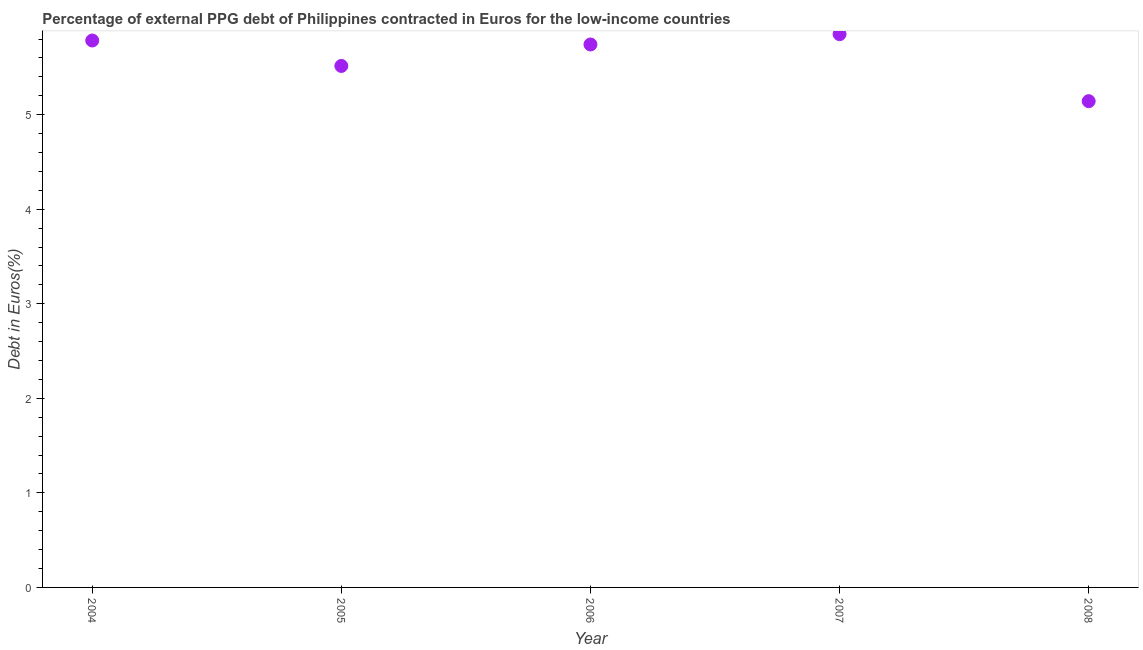What is the currency composition of ppg debt in 2004?
Your response must be concise. 5.79. Across all years, what is the maximum currency composition of ppg debt?
Offer a terse response. 5.85. Across all years, what is the minimum currency composition of ppg debt?
Ensure brevity in your answer.  5.14. In which year was the currency composition of ppg debt maximum?
Offer a terse response. 2007. In which year was the currency composition of ppg debt minimum?
Provide a short and direct response. 2008. What is the sum of the currency composition of ppg debt?
Make the answer very short. 28.04. What is the difference between the currency composition of ppg debt in 2005 and 2007?
Provide a short and direct response. -0.34. What is the average currency composition of ppg debt per year?
Your response must be concise. 5.61. What is the median currency composition of ppg debt?
Your answer should be compact. 5.74. In how many years, is the currency composition of ppg debt greater than 4.2 %?
Your response must be concise. 5. Do a majority of the years between 2006 and 2008 (inclusive) have currency composition of ppg debt greater than 0.2 %?
Your answer should be very brief. Yes. What is the ratio of the currency composition of ppg debt in 2004 to that in 2006?
Provide a succinct answer. 1.01. Is the difference between the currency composition of ppg debt in 2006 and 2007 greater than the difference between any two years?
Offer a terse response. No. What is the difference between the highest and the second highest currency composition of ppg debt?
Your answer should be compact. 0.07. What is the difference between the highest and the lowest currency composition of ppg debt?
Your answer should be compact. 0.71. Does the currency composition of ppg debt monotonically increase over the years?
Ensure brevity in your answer.  No. How many dotlines are there?
Offer a terse response. 1. Does the graph contain any zero values?
Your response must be concise. No. Does the graph contain grids?
Your answer should be very brief. No. What is the title of the graph?
Provide a short and direct response. Percentage of external PPG debt of Philippines contracted in Euros for the low-income countries. What is the label or title of the Y-axis?
Your response must be concise. Debt in Euros(%). What is the Debt in Euros(%) in 2004?
Your response must be concise. 5.79. What is the Debt in Euros(%) in 2005?
Give a very brief answer. 5.52. What is the Debt in Euros(%) in 2006?
Your response must be concise. 5.74. What is the Debt in Euros(%) in 2007?
Keep it short and to the point. 5.85. What is the Debt in Euros(%) in 2008?
Your answer should be compact. 5.14. What is the difference between the Debt in Euros(%) in 2004 and 2005?
Ensure brevity in your answer.  0.27. What is the difference between the Debt in Euros(%) in 2004 and 2006?
Your answer should be compact. 0.04. What is the difference between the Debt in Euros(%) in 2004 and 2007?
Your response must be concise. -0.07. What is the difference between the Debt in Euros(%) in 2004 and 2008?
Keep it short and to the point. 0.64. What is the difference between the Debt in Euros(%) in 2005 and 2006?
Your answer should be very brief. -0.23. What is the difference between the Debt in Euros(%) in 2005 and 2007?
Keep it short and to the point. -0.34. What is the difference between the Debt in Euros(%) in 2005 and 2008?
Provide a short and direct response. 0.37. What is the difference between the Debt in Euros(%) in 2006 and 2007?
Keep it short and to the point. -0.11. What is the difference between the Debt in Euros(%) in 2006 and 2008?
Your answer should be compact. 0.6. What is the difference between the Debt in Euros(%) in 2007 and 2008?
Offer a very short reply. 0.71. What is the ratio of the Debt in Euros(%) in 2004 to that in 2005?
Provide a succinct answer. 1.05. What is the ratio of the Debt in Euros(%) in 2005 to that in 2007?
Keep it short and to the point. 0.94. What is the ratio of the Debt in Euros(%) in 2005 to that in 2008?
Your response must be concise. 1.07. What is the ratio of the Debt in Euros(%) in 2006 to that in 2008?
Your response must be concise. 1.12. What is the ratio of the Debt in Euros(%) in 2007 to that in 2008?
Your response must be concise. 1.14. 